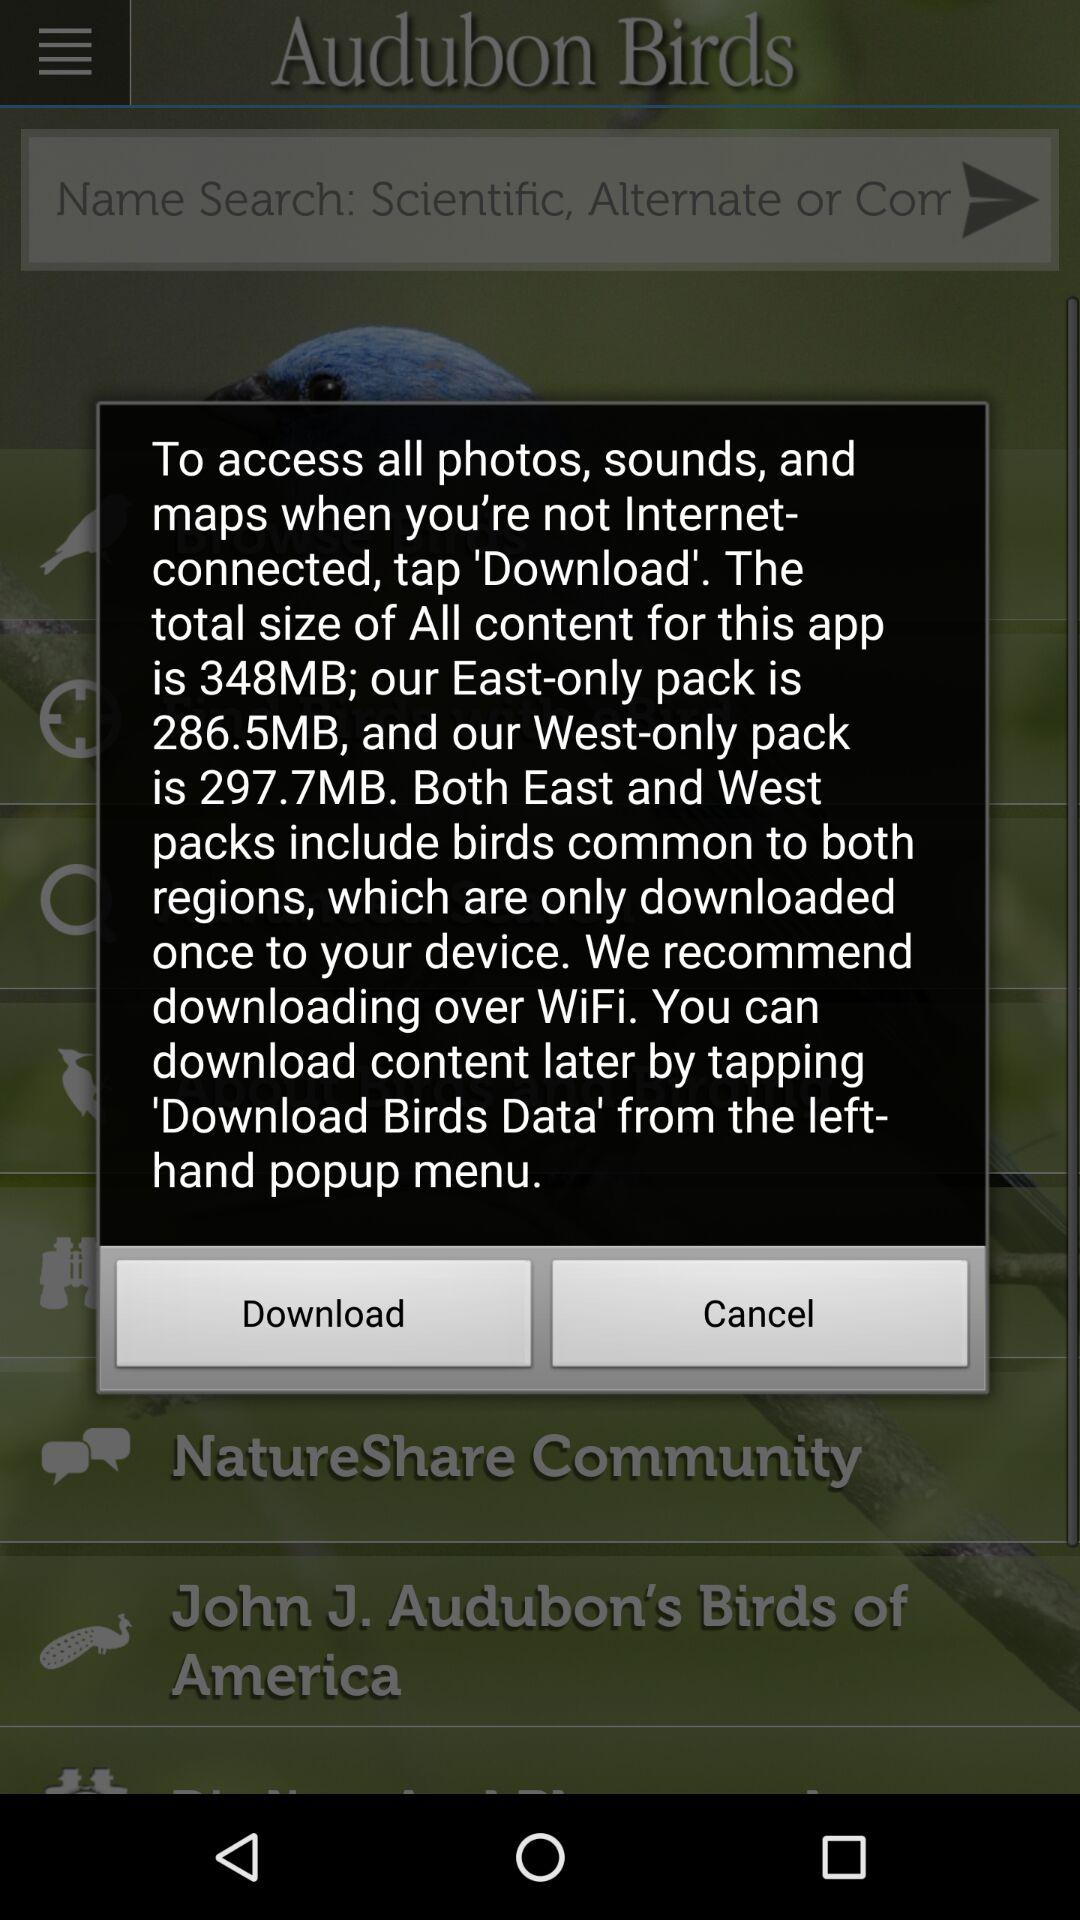How much more data does the West-only pack require than the East-only pack?
Answer the question using a single word or phrase. 11.2MB 